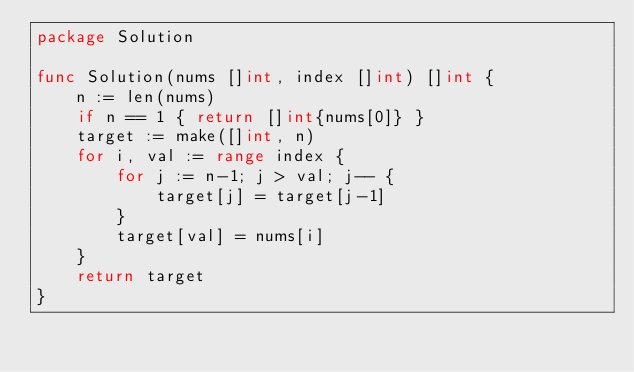<code> <loc_0><loc_0><loc_500><loc_500><_Go_>package Solution

func Solution(nums []int, index []int) []int {
    n := len(nums)
    if n == 1 { return []int{nums[0]} }
    target := make([]int, n)
    for i, val := range index {
        for j := n-1; j > val; j-- {
            target[j] = target[j-1]
        }
        target[val] = nums[i]
    }
    return target
}
</code> 